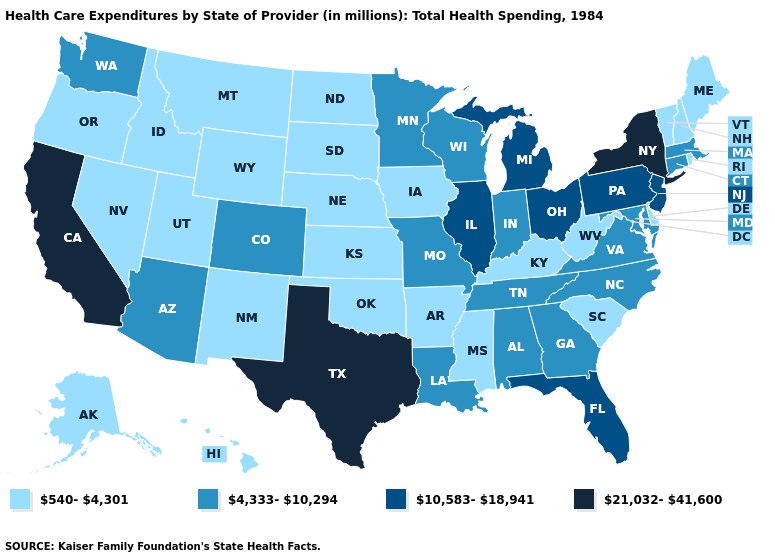What is the highest value in the USA?
Short answer required. 21,032-41,600. What is the value of Texas?
Short answer required. 21,032-41,600. Does Utah have a lower value than Washington?
Concise answer only. Yes. Which states have the lowest value in the South?
Give a very brief answer. Arkansas, Delaware, Kentucky, Mississippi, Oklahoma, South Carolina, West Virginia. What is the value of Maine?
Be succinct. 540-4,301. How many symbols are there in the legend?
Keep it brief. 4. Name the states that have a value in the range 4,333-10,294?
Be succinct. Alabama, Arizona, Colorado, Connecticut, Georgia, Indiana, Louisiana, Maryland, Massachusetts, Minnesota, Missouri, North Carolina, Tennessee, Virginia, Washington, Wisconsin. Name the states that have a value in the range 540-4,301?
Give a very brief answer. Alaska, Arkansas, Delaware, Hawaii, Idaho, Iowa, Kansas, Kentucky, Maine, Mississippi, Montana, Nebraska, Nevada, New Hampshire, New Mexico, North Dakota, Oklahoma, Oregon, Rhode Island, South Carolina, South Dakota, Utah, Vermont, West Virginia, Wyoming. Which states have the lowest value in the USA?
Keep it brief. Alaska, Arkansas, Delaware, Hawaii, Idaho, Iowa, Kansas, Kentucky, Maine, Mississippi, Montana, Nebraska, Nevada, New Hampshire, New Mexico, North Dakota, Oklahoma, Oregon, Rhode Island, South Carolina, South Dakota, Utah, Vermont, West Virginia, Wyoming. Name the states that have a value in the range 10,583-18,941?
Be succinct. Florida, Illinois, Michigan, New Jersey, Ohio, Pennsylvania. Name the states that have a value in the range 4,333-10,294?
Concise answer only. Alabama, Arizona, Colorado, Connecticut, Georgia, Indiana, Louisiana, Maryland, Massachusetts, Minnesota, Missouri, North Carolina, Tennessee, Virginia, Washington, Wisconsin. What is the value of Louisiana?
Short answer required. 4,333-10,294. Does Maine have a lower value than Minnesota?
Quick response, please. Yes. Among the states that border New Hampshire , which have the highest value?
Be succinct. Massachusetts. Does New York have the highest value in the USA?
Give a very brief answer. Yes. 